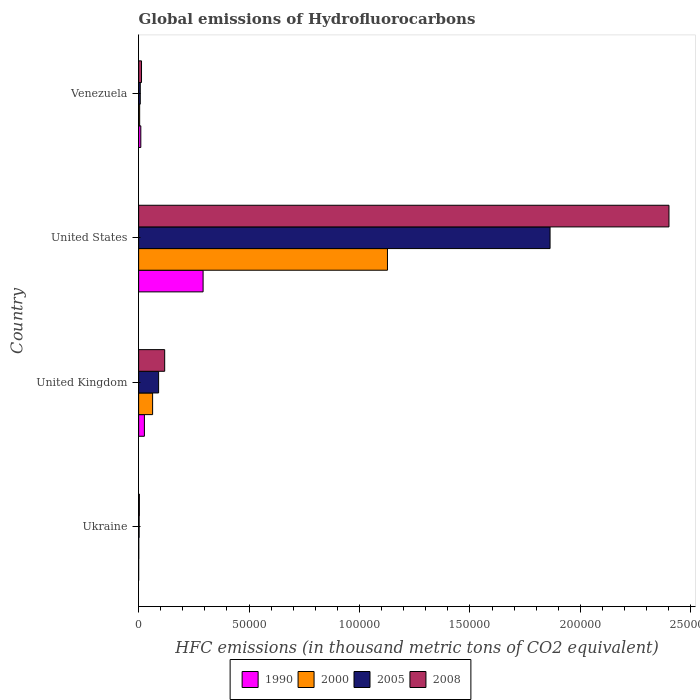What is the label of the 2nd group of bars from the top?
Your answer should be compact. United States. In how many cases, is the number of bars for a given country not equal to the number of legend labels?
Keep it short and to the point. 0. What is the global emissions of Hydrofluorocarbons in 2000 in United States?
Provide a short and direct response. 1.13e+05. Across all countries, what is the maximum global emissions of Hydrofluorocarbons in 2005?
Make the answer very short. 1.86e+05. Across all countries, what is the minimum global emissions of Hydrofluorocarbons in 2008?
Your answer should be compact. 333.5. In which country was the global emissions of Hydrofluorocarbons in 2000 maximum?
Your answer should be compact. United States. In which country was the global emissions of Hydrofluorocarbons in 2008 minimum?
Offer a terse response. Ukraine. What is the total global emissions of Hydrofluorocarbons in 2005 in the graph?
Keep it short and to the point. 1.96e+05. What is the difference between the global emissions of Hydrofluorocarbons in 2000 in Ukraine and that in United Kingdom?
Keep it short and to the point. -6277.8. What is the difference between the global emissions of Hydrofluorocarbons in 1990 in Venezuela and the global emissions of Hydrofluorocarbons in 2008 in United Kingdom?
Ensure brevity in your answer.  -1.08e+04. What is the average global emissions of Hydrofluorocarbons in 2000 per country?
Offer a very short reply. 2.99e+04. What is the difference between the global emissions of Hydrofluorocarbons in 1990 and global emissions of Hydrofluorocarbons in 2005 in United States?
Keep it short and to the point. -1.57e+05. What is the ratio of the global emissions of Hydrofluorocarbons in 2005 in United Kingdom to that in United States?
Your answer should be very brief. 0.05. Is the global emissions of Hydrofluorocarbons in 2008 in United Kingdom less than that in United States?
Your response must be concise. Yes. What is the difference between the highest and the second highest global emissions of Hydrofluorocarbons in 2000?
Provide a succinct answer. 1.06e+05. What is the difference between the highest and the lowest global emissions of Hydrofluorocarbons in 1990?
Provide a succinct answer. 2.92e+04. Is the sum of the global emissions of Hydrofluorocarbons in 1990 in United Kingdom and United States greater than the maximum global emissions of Hydrofluorocarbons in 2000 across all countries?
Offer a terse response. No. Is it the case that in every country, the sum of the global emissions of Hydrofluorocarbons in 2008 and global emissions of Hydrofluorocarbons in 2005 is greater than the sum of global emissions of Hydrofluorocarbons in 1990 and global emissions of Hydrofluorocarbons in 2000?
Offer a very short reply. No. What does the 3rd bar from the top in Ukraine represents?
Give a very brief answer. 2000. Are all the bars in the graph horizontal?
Provide a succinct answer. Yes. What is the difference between two consecutive major ticks on the X-axis?
Make the answer very short. 5.00e+04. Are the values on the major ticks of X-axis written in scientific E-notation?
Provide a short and direct response. No. Does the graph contain any zero values?
Your answer should be very brief. No. Where does the legend appear in the graph?
Ensure brevity in your answer.  Bottom center. What is the title of the graph?
Provide a short and direct response. Global emissions of Hydrofluorocarbons. What is the label or title of the X-axis?
Give a very brief answer. HFC emissions (in thousand metric tons of CO2 equivalent). What is the label or title of the Y-axis?
Provide a succinct answer. Country. What is the HFC emissions (in thousand metric tons of CO2 equivalent) of 1990 in Ukraine?
Your answer should be very brief. 0.1. What is the HFC emissions (in thousand metric tons of CO2 equivalent) of 2000 in Ukraine?
Your answer should be compact. 54.7. What is the HFC emissions (in thousand metric tons of CO2 equivalent) of 2005 in Ukraine?
Keep it short and to the point. 227.2. What is the HFC emissions (in thousand metric tons of CO2 equivalent) of 2008 in Ukraine?
Offer a very short reply. 333.5. What is the HFC emissions (in thousand metric tons of CO2 equivalent) in 1990 in United Kingdom?
Provide a succinct answer. 2617.8. What is the HFC emissions (in thousand metric tons of CO2 equivalent) in 2000 in United Kingdom?
Ensure brevity in your answer.  6332.5. What is the HFC emissions (in thousand metric tons of CO2 equivalent) in 2005 in United Kingdom?
Your response must be concise. 9043.4. What is the HFC emissions (in thousand metric tons of CO2 equivalent) of 2008 in United Kingdom?
Offer a very short reply. 1.18e+04. What is the HFC emissions (in thousand metric tons of CO2 equivalent) of 1990 in United States?
Provide a succinct answer. 2.92e+04. What is the HFC emissions (in thousand metric tons of CO2 equivalent) in 2000 in United States?
Your answer should be compact. 1.13e+05. What is the HFC emissions (in thousand metric tons of CO2 equivalent) in 2005 in United States?
Ensure brevity in your answer.  1.86e+05. What is the HFC emissions (in thousand metric tons of CO2 equivalent) of 2008 in United States?
Offer a terse response. 2.40e+05. What is the HFC emissions (in thousand metric tons of CO2 equivalent) in 1990 in Venezuela?
Keep it short and to the point. 989.6. What is the HFC emissions (in thousand metric tons of CO2 equivalent) in 2000 in Venezuela?
Provide a short and direct response. 468.5. What is the HFC emissions (in thousand metric tons of CO2 equivalent) in 2005 in Venezuela?
Your answer should be compact. 738.4. What is the HFC emissions (in thousand metric tons of CO2 equivalent) of 2008 in Venezuela?
Provide a short and direct response. 1307.1. Across all countries, what is the maximum HFC emissions (in thousand metric tons of CO2 equivalent) of 1990?
Your answer should be compact. 2.92e+04. Across all countries, what is the maximum HFC emissions (in thousand metric tons of CO2 equivalent) in 2000?
Provide a short and direct response. 1.13e+05. Across all countries, what is the maximum HFC emissions (in thousand metric tons of CO2 equivalent) of 2005?
Your answer should be very brief. 1.86e+05. Across all countries, what is the maximum HFC emissions (in thousand metric tons of CO2 equivalent) of 2008?
Ensure brevity in your answer.  2.40e+05. Across all countries, what is the minimum HFC emissions (in thousand metric tons of CO2 equivalent) of 1990?
Give a very brief answer. 0.1. Across all countries, what is the minimum HFC emissions (in thousand metric tons of CO2 equivalent) of 2000?
Offer a terse response. 54.7. Across all countries, what is the minimum HFC emissions (in thousand metric tons of CO2 equivalent) in 2005?
Keep it short and to the point. 227.2. Across all countries, what is the minimum HFC emissions (in thousand metric tons of CO2 equivalent) of 2008?
Your answer should be very brief. 333.5. What is the total HFC emissions (in thousand metric tons of CO2 equivalent) in 1990 in the graph?
Offer a terse response. 3.28e+04. What is the total HFC emissions (in thousand metric tons of CO2 equivalent) of 2000 in the graph?
Offer a very short reply. 1.20e+05. What is the total HFC emissions (in thousand metric tons of CO2 equivalent) of 2005 in the graph?
Offer a very short reply. 1.96e+05. What is the total HFC emissions (in thousand metric tons of CO2 equivalent) in 2008 in the graph?
Ensure brevity in your answer.  2.54e+05. What is the difference between the HFC emissions (in thousand metric tons of CO2 equivalent) of 1990 in Ukraine and that in United Kingdom?
Your answer should be very brief. -2617.7. What is the difference between the HFC emissions (in thousand metric tons of CO2 equivalent) of 2000 in Ukraine and that in United Kingdom?
Your response must be concise. -6277.8. What is the difference between the HFC emissions (in thousand metric tons of CO2 equivalent) of 2005 in Ukraine and that in United Kingdom?
Provide a succinct answer. -8816.2. What is the difference between the HFC emissions (in thousand metric tons of CO2 equivalent) in 2008 in Ukraine and that in United Kingdom?
Keep it short and to the point. -1.15e+04. What is the difference between the HFC emissions (in thousand metric tons of CO2 equivalent) of 1990 in Ukraine and that in United States?
Offer a very short reply. -2.92e+04. What is the difference between the HFC emissions (in thousand metric tons of CO2 equivalent) in 2000 in Ukraine and that in United States?
Make the answer very short. -1.13e+05. What is the difference between the HFC emissions (in thousand metric tons of CO2 equivalent) in 2005 in Ukraine and that in United States?
Make the answer very short. -1.86e+05. What is the difference between the HFC emissions (in thousand metric tons of CO2 equivalent) in 2008 in Ukraine and that in United States?
Offer a very short reply. -2.40e+05. What is the difference between the HFC emissions (in thousand metric tons of CO2 equivalent) of 1990 in Ukraine and that in Venezuela?
Your response must be concise. -989.5. What is the difference between the HFC emissions (in thousand metric tons of CO2 equivalent) of 2000 in Ukraine and that in Venezuela?
Your answer should be compact. -413.8. What is the difference between the HFC emissions (in thousand metric tons of CO2 equivalent) of 2005 in Ukraine and that in Venezuela?
Your response must be concise. -511.2. What is the difference between the HFC emissions (in thousand metric tons of CO2 equivalent) of 2008 in Ukraine and that in Venezuela?
Your answer should be compact. -973.6. What is the difference between the HFC emissions (in thousand metric tons of CO2 equivalent) in 1990 in United Kingdom and that in United States?
Your answer should be very brief. -2.66e+04. What is the difference between the HFC emissions (in thousand metric tons of CO2 equivalent) of 2000 in United Kingdom and that in United States?
Your answer should be very brief. -1.06e+05. What is the difference between the HFC emissions (in thousand metric tons of CO2 equivalent) in 2005 in United Kingdom and that in United States?
Your answer should be very brief. -1.77e+05. What is the difference between the HFC emissions (in thousand metric tons of CO2 equivalent) in 2008 in United Kingdom and that in United States?
Offer a very short reply. -2.28e+05. What is the difference between the HFC emissions (in thousand metric tons of CO2 equivalent) of 1990 in United Kingdom and that in Venezuela?
Your answer should be compact. 1628.2. What is the difference between the HFC emissions (in thousand metric tons of CO2 equivalent) in 2000 in United Kingdom and that in Venezuela?
Offer a terse response. 5864. What is the difference between the HFC emissions (in thousand metric tons of CO2 equivalent) of 2005 in United Kingdom and that in Venezuela?
Keep it short and to the point. 8305. What is the difference between the HFC emissions (in thousand metric tons of CO2 equivalent) in 2008 in United Kingdom and that in Venezuela?
Your answer should be very brief. 1.05e+04. What is the difference between the HFC emissions (in thousand metric tons of CO2 equivalent) of 1990 in United States and that in Venezuela?
Keep it short and to the point. 2.82e+04. What is the difference between the HFC emissions (in thousand metric tons of CO2 equivalent) of 2000 in United States and that in Venezuela?
Offer a very short reply. 1.12e+05. What is the difference between the HFC emissions (in thousand metric tons of CO2 equivalent) of 2005 in United States and that in Venezuela?
Offer a very short reply. 1.86e+05. What is the difference between the HFC emissions (in thousand metric tons of CO2 equivalent) in 2008 in United States and that in Venezuela?
Give a very brief answer. 2.39e+05. What is the difference between the HFC emissions (in thousand metric tons of CO2 equivalent) of 1990 in Ukraine and the HFC emissions (in thousand metric tons of CO2 equivalent) of 2000 in United Kingdom?
Make the answer very short. -6332.4. What is the difference between the HFC emissions (in thousand metric tons of CO2 equivalent) of 1990 in Ukraine and the HFC emissions (in thousand metric tons of CO2 equivalent) of 2005 in United Kingdom?
Ensure brevity in your answer.  -9043.3. What is the difference between the HFC emissions (in thousand metric tons of CO2 equivalent) in 1990 in Ukraine and the HFC emissions (in thousand metric tons of CO2 equivalent) in 2008 in United Kingdom?
Ensure brevity in your answer.  -1.18e+04. What is the difference between the HFC emissions (in thousand metric tons of CO2 equivalent) in 2000 in Ukraine and the HFC emissions (in thousand metric tons of CO2 equivalent) in 2005 in United Kingdom?
Keep it short and to the point. -8988.7. What is the difference between the HFC emissions (in thousand metric tons of CO2 equivalent) of 2000 in Ukraine and the HFC emissions (in thousand metric tons of CO2 equivalent) of 2008 in United Kingdom?
Keep it short and to the point. -1.17e+04. What is the difference between the HFC emissions (in thousand metric tons of CO2 equivalent) of 2005 in Ukraine and the HFC emissions (in thousand metric tons of CO2 equivalent) of 2008 in United Kingdom?
Your response must be concise. -1.16e+04. What is the difference between the HFC emissions (in thousand metric tons of CO2 equivalent) in 1990 in Ukraine and the HFC emissions (in thousand metric tons of CO2 equivalent) in 2000 in United States?
Your response must be concise. -1.13e+05. What is the difference between the HFC emissions (in thousand metric tons of CO2 equivalent) of 1990 in Ukraine and the HFC emissions (in thousand metric tons of CO2 equivalent) of 2005 in United States?
Provide a succinct answer. -1.86e+05. What is the difference between the HFC emissions (in thousand metric tons of CO2 equivalent) of 1990 in Ukraine and the HFC emissions (in thousand metric tons of CO2 equivalent) of 2008 in United States?
Give a very brief answer. -2.40e+05. What is the difference between the HFC emissions (in thousand metric tons of CO2 equivalent) in 2000 in Ukraine and the HFC emissions (in thousand metric tons of CO2 equivalent) in 2005 in United States?
Make the answer very short. -1.86e+05. What is the difference between the HFC emissions (in thousand metric tons of CO2 equivalent) in 2000 in Ukraine and the HFC emissions (in thousand metric tons of CO2 equivalent) in 2008 in United States?
Your answer should be compact. -2.40e+05. What is the difference between the HFC emissions (in thousand metric tons of CO2 equivalent) in 2005 in Ukraine and the HFC emissions (in thousand metric tons of CO2 equivalent) in 2008 in United States?
Provide a succinct answer. -2.40e+05. What is the difference between the HFC emissions (in thousand metric tons of CO2 equivalent) of 1990 in Ukraine and the HFC emissions (in thousand metric tons of CO2 equivalent) of 2000 in Venezuela?
Your answer should be very brief. -468.4. What is the difference between the HFC emissions (in thousand metric tons of CO2 equivalent) of 1990 in Ukraine and the HFC emissions (in thousand metric tons of CO2 equivalent) of 2005 in Venezuela?
Your answer should be compact. -738.3. What is the difference between the HFC emissions (in thousand metric tons of CO2 equivalent) of 1990 in Ukraine and the HFC emissions (in thousand metric tons of CO2 equivalent) of 2008 in Venezuela?
Your response must be concise. -1307. What is the difference between the HFC emissions (in thousand metric tons of CO2 equivalent) in 2000 in Ukraine and the HFC emissions (in thousand metric tons of CO2 equivalent) in 2005 in Venezuela?
Provide a short and direct response. -683.7. What is the difference between the HFC emissions (in thousand metric tons of CO2 equivalent) of 2000 in Ukraine and the HFC emissions (in thousand metric tons of CO2 equivalent) of 2008 in Venezuela?
Keep it short and to the point. -1252.4. What is the difference between the HFC emissions (in thousand metric tons of CO2 equivalent) of 2005 in Ukraine and the HFC emissions (in thousand metric tons of CO2 equivalent) of 2008 in Venezuela?
Your answer should be compact. -1079.9. What is the difference between the HFC emissions (in thousand metric tons of CO2 equivalent) in 1990 in United Kingdom and the HFC emissions (in thousand metric tons of CO2 equivalent) in 2000 in United States?
Your response must be concise. -1.10e+05. What is the difference between the HFC emissions (in thousand metric tons of CO2 equivalent) in 1990 in United Kingdom and the HFC emissions (in thousand metric tons of CO2 equivalent) in 2005 in United States?
Your answer should be compact. -1.84e+05. What is the difference between the HFC emissions (in thousand metric tons of CO2 equivalent) in 1990 in United Kingdom and the HFC emissions (in thousand metric tons of CO2 equivalent) in 2008 in United States?
Your response must be concise. -2.38e+05. What is the difference between the HFC emissions (in thousand metric tons of CO2 equivalent) of 2000 in United Kingdom and the HFC emissions (in thousand metric tons of CO2 equivalent) of 2005 in United States?
Offer a terse response. -1.80e+05. What is the difference between the HFC emissions (in thousand metric tons of CO2 equivalent) in 2000 in United Kingdom and the HFC emissions (in thousand metric tons of CO2 equivalent) in 2008 in United States?
Provide a short and direct response. -2.34e+05. What is the difference between the HFC emissions (in thousand metric tons of CO2 equivalent) of 2005 in United Kingdom and the HFC emissions (in thousand metric tons of CO2 equivalent) of 2008 in United States?
Offer a very short reply. -2.31e+05. What is the difference between the HFC emissions (in thousand metric tons of CO2 equivalent) of 1990 in United Kingdom and the HFC emissions (in thousand metric tons of CO2 equivalent) of 2000 in Venezuela?
Provide a short and direct response. 2149.3. What is the difference between the HFC emissions (in thousand metric tons of CO2 equivalent) in 1990 in United Kingdom and the HFC emissions (in thousand metric tons of CO2 equivalent) in 2005 in Venezuela?
Provide a short and direct response. 1879.4. What is the difference between the HFC emissions (in thousand metric tons of CO2 equivalent) of 1990 in United Kingdom and the HFC emissions (in thousand metric tons of CO2 equivalent) of 2008 in Venezuela?
Keep it short and to the point. 1310.7. What is the difference between the HFC emissions (in thousand metric tons of CO2 equivalent) in 2000 in United Kingdom and the HFC emissions (in thousand metric tons of CO2 equivalent) in 2005 in Venezuela?
Offer a very short reply. 5594.1. What is the difference between the HFC emissions (in thousand metric tons of CO2 equivalent) of 2000 in United Kingdom and the HFC emissions (in thousand metric tons of CO2 equivalent) of 2008 in Venezuela?
Keep it short and to the point. 5025.4. What is the difference between the HFC emissions (in thousand metric tons of CO2 equivalent) in 2005 in United Kingdom and the HFC emissions (in thousand metric tons of CO2 equivalent) in 2008 in Venezuela?
Your answer should be very brief. 7736.3. What is the difference between the HFC emissions (in thousand metric tons of CO2 equivalent) in 1990 in United States and the HFC emissions (in thousand metric tons of CO2 equivalent) in 2000 in Venezuela?
Keep it short and to the point. 2.87e+04. What is the difference between the HFC emissions (in thousand metric tons of CO2 equivalent) in 1990 in United States and the HFC emissions (in thousand metric tons of CO2 equivalent) in 2005 in Venezuela?
Your answer should be very brief. 2.84e+04. What is the difference between the HFC emissions (in thousand metric tons of CO2 equivalent) in 1990 in United States and the HFC emissions (in thousand metric tons of CO2 equivalent) in 2008 in Venezuela?
Your answer should be compact. 2.79e+04. What is the difference between the HFC emissions (in thousand metric tons of CO2 equivalent) of 2000 in United States and the HFC emissions (in thousand metric tons of CO2 equivalent) of 2005 in Venezuela?
Offer a very short reply. 1.12e+05. What is the difference between the HFC emissions (in thousand metric tons of CO2 equivalent) of 2000 in United States and the HFC emissions (in thousand metric tons of CO2 equivalent) of 2008 in Venezuela?
Provide a short and direct response. 1.11e+05. What is the difference between the HFC emissions (in thousand metric tons of CO2 equivalent) in 2005 in United States and the HFC emissions (in thousand metric tons of CO2 equivalent) in 2008 in Venezuela?
Your answer should be compact. 1.85e+05. What is the average HFC emissions (in thousand metric tons of CO2 equivalent) in 1990 per country?
Offer a very short reply. 8198.33. What is the average HFC emissions (in thousand metric tons of CO2 equivalent) in 2000 per country?
Your answer should be very brief. 2.99e+04. What is the average HFC emissions (in thousand metric tons of CO2 equivalent) of 2005 per country?
Your response must be concise. 4.91e+04. What is the average HFC emissions (in thousand metric tons of CO2 equivalent) in 2008 per country?
Your answer should be compact. 6.34e+04. What is the difference between the HFC emissions (in thousand metric tons of CO2 equivalent) in 1990 and HFC emissions (in thousand metric tons of CO2 equivalent) in 2000 in Ukraine?
Your answer should be very brief. -54.6. What is the difference between the HFC emissions (in thousand metric tons of CO2 equivalent) in 1990 and HFC emissions (in thousand metric tons of CO2 equivalent) in 2005 in Ukraine?
Provide a short and direct response. -227.1. What is the difference between the HFC emissions (in thousand metric tons of CO2 equivalent) of 1990 and HFC emissions (in thousand metric tons of CO2 equivalent) of 2008 in Ukraine?
Your answer should be very brief. -333.4. What is the difference between the HFC emissions (in thousand metric tons of CO2 equivalent) in 2000 and HFC emissions (in thousand metric tons of CO2 equivalent) in 2005 in Ukraine?
Offer a terse response. -172.5. What is the difference between the HFC emissions (in thousand metric tons of CO2 equivalent) of 2000 and HFC emissions (in thousand metric tons of CO2 equivalent) of 2008 in Ukraine?
Keep it short and to the point. -278.8. What is the difference between the HFC emissions (in thousand metric tons of CO2 equivalent) of 2005 and HFC emissions (in thousand metric tons of CO2 equivalent) of 2008 in Ukraine?
Give a very brief answer. -106.3. What is the difference between the HFC emissions (in thousand metric tons of CO2 equivalent) of 1990 and HFC emissions (in thousand metric tons of CO2 equivalent) of 2000 in United Kingdom?
Give a very brief answer. -3714.7. What is the difference between the HFC emissions (in thousand metric tons of CO2 equivalent) of 1990 and HFC emissions (in thousand metric tons of CO2 equivalent) of 2005 in United Kingdom?
Ensure brevity in your answer.  -6425.6. What is the difference between the HFC emissions (in thousand metric tons of CO2 equivalent) of 1990 and HFC emissions (in thousand metric tons of CO2 equivalent) of 2008 in United Kingdom?
Ensure brevity in your answer.  -9178.2. What is the difference between the HFC emissions (in thousand metric tons of CO2 equivalent) in 2000 and HFC emissions (in thousand metric tons of CO2 equivalent) in 2005 in United Kingdom?
Ensure brevity in your answer.  -2710.9. What is the difference between the HFC emissions (in thousand metric tons of CO2 equivalent) in 2000 and HFC emissions (in thousand metric tons of CO2 equivalent) in 2008 in United Kingdom?
Make the answer very short. -5463.5. What is the difference between the HFC emissions (in thousand metric tons of CO2 equivalent) of 2005 and HFC emissions (in thousand metric tons of CO2 equivalent) of 2008 in United Kingdom?
Your answer should be very brief. -2752.6. What is the difference between the HFC emissions (in thousand metric tons of CO2 equivalent) of 1990 and HFC emissions (in thousand metric tons of CO2 equivalent) of 2000 in United States?
Make the answer very short. -8.35e+04. What is the difference between the HFC emissions (in thousand metric tons of CO2 equivalent) in 1990 and HFC emissions (in thousand metric tons of CO2 equivalent) in 2005 in United States?
Keep it short and to the point. -1.57e+05. What is the difference between the HFC emissions (in thousand metric tons of CO2 equivalent) of 1990 and HFC emissions (in thousand metric tons of CO2 equivalent) of 2008 in United States?
Ensure brevity in your answer.  -2.11e+05. What is the difference between the HFC emissions (in thousand metric tons of CO2 equivalent) in 2000 and HFC emissions (in thousand metric tons of CO2 equivalent) in 2005 in United States?
Your answer should be compact. -7.36e+04. What is the difference between the HFC emissions (in thousand metric tons of CO2 equivalent) in 2000 and HFC emissions (in thousand metric tons of CO2 equivalent) in 2008 in United States?
Your response must be concise. -1.27e+05. What is the difference between the HFC emissions (in thousand metric tons of CO2 equivalent) of 2005 and HFC emissions (in thousand metric tons of CO2 equivalent) of 2008 in United States?
Your response must be concise. -5.38e+04. What is the difference between the HFC emissions (in thousand metric tons of CO2 equivalent) of 1990 and HFC emissions (in thousand metric tons of CO2 equivalent) of 2000 in Venezuela?
Offer a terse response. 521.1. What is the difference between the HFC emissions (in thousand metric tons of CO2 equivalent) in 1990 and HFC emissions (in thousand metric tons of CO2 equivalent) in 2005 in Venezuela?
Make the answer very short. 251.2. What is the difference between the HFC emissions (in thousand metric tons of CO2 equivalent) in 1990 and HFC emissions (in thousand metric tons of CO2 equivalent) in 2008 in Venezuela?
Give a very brief answer. -317.5. What is the difference between the HFC emissions (in thousand metric tons of CO2 equivalent) of 2000 and HFC emissions (in thousand metric tons of CO2 equivalent) of 2005 in Venezuela?
Ensure brevity in your answer.  -269.9. What is the difference between the HFC emissions (in thousand metric tons of CO2 equivalent) of 2000 and HFC emissions (in thousand metric tons of CO2 equivalent) of 2008 in Venezuela?
Ensure brevity in your answer.  -838.6. What is the difference between the HFC emissions (in thousand metric tons of CO2 equivalent) in 2005 and HFC emissions (in thousand metric tons of CO2 equivalent) in 2008 in Venezuela?
Your answer should be very brief. -568.7. What is the ratio of the HFC emissions (in thousand metric tons of CO2 equivalent) in 1990 in Ukraine to that in United Kingdom?
Give a very brief answer. 0. What is the ratio of the HFC emissions (in thousand metric tons of CO2 equivalent) in 2000 in Ukraine to that in United Kingdom?
Give a very brief answer. 0.01. What is the ratio of the HFC emissions (in thousand metric tons of CO2 equivalent) in 2005 in Ukraine to that in United Kingdom?
Offer a terse response. 0.03. What is the ratio of the HFC emissions (in thousand metric tons of CO2 equivalent) in 2008 in Ukraine to that in United Kingdom?
Your answer should be very brief. 0.03. What is the ratio of the HFC emissions (in thousand metric tons of CO2 equivalent) of 1990 in Ukraine to that in United States?
Offer a very short reply. 0. What is the ratio of the HFC emissions (in thousand metric tons of CO2 equivalent) of 2000 in Ukraine to that in United States?
Provide a short and direct response. 0. What is the ratio of the HFC emissions (in thousand metric tons of CO2 equivalent) in 2005 in Ukraine to that in United States?
Your answer should be very brief. 0. What is the ratio of the HFC emissions (in thousand metric tons of CO2 equivalent) in 2008 in Ukraine to that in United States?
Your response must be concise. 0. What is the ratio of the HFC emissions (in thousand metric tons of CO2 equivalent) of 2000 in Ukraine to that in Venezuela?
Make the answer very short. 0.12. What is the ratio of the HFC emissions (in thousand metric tons of CO2 equivalent) of 2005 in Ukraine to that in Venezuela?
Your answer should be compact. 0.31. What is the ratio of the HFC emissions (in thousand metric tons of CO2 equivalent) of 2008 in Ukraine to that in Venezuela?
Offer a very short reply. 0.26. What is the ratio of the HFC emissions (in thousand metric tons of CO2 equivalent) of 1990 in United Kingdom to that in United States?
Your answer should be compact. 0.09. What is the ratio of the HFC emissions (in thousand metric tons of CO2 equivalent) in 2000 in United Kingdom to that in United States?
Your answer should be very brief. 0.06. What is the ratio of the HFC emissions (in thousand metric tons of CO2 equivalent) in 2005 in United Kingdom to that in United States?
Keep it short and to the point. 0.05. What is the ratio of the HFC emissions (in thousand metric tons of CO2 equivalent) of 2008 in United Kingdom to that in United States?
Your answer should be compact. 0.05. What is the ratio of the HFC emissions (in thousand metric tons of CO2 equivalent) in 1990 in United Kingdom to that in Venezuela?
Provide a succinct answer. 2.65. What is the ratio of the HFC emissions (in thousand metric tons of CO2 equivalent) of 2000 in United Kingdom to that in Venezuela?
Keep it short and to the point. 13.52. What is the ratio of the HFC emissions (in thousand metric tons of CO2 equivalent) in 2005 in United Kingdom to that in Venezuela?
Make the answer very short. 12.25. What is the ratio of the HFC emissions (in thousand metric tons of CO2 equivalent) in 2008 in United Kingdom to that in Venezuela?
Keep it short and to the point. 9.02. What is the ratio of the HFC emissions (in thousand metric tons of CO2 equivalent) of 1990 in United States to that in Venezuela?
Ensure brevity in your answer.  29.49. What is the ratio of the HFC emissions (in thousand metric tons of CO2 equivalent) of 2000 in United States to that in Venezuela?
Your response must be concise. 240.48. What is the ratio of the HFC emissions (in thousand metric tons of CO2 equivalent) of 2005 in United States to that in Venezuela?
Provide a succinct answer. 252.29. What is the ratio of the HFC emissions (in thousand metric tons of CO2 equivalent) of 2008 in United States to that in Venezuela?
Your answer should be very brief. 183.71. What is the difference between the highest and the second highest HFC emissions (in thousand metric tons of CO2 equivalent) of 1990?
Make the answer very short. 2.66e+04. What is the difference between the highest and the second highest HFC emissions (in thousand metric tons of CO2 equivalent) in 2000?
Offer a very short reply. 1.06e+05. What is the difference between the highest and the second highest HFC emissions (in thousand metric tons of CO2 equivalent) of 2005?
Provide a short and direct response. 1.77e+05. What is the difference between the highest and the second highest HFC emissions (in thousand metric tons of CO2 equivalent) in 2008?
Ensure brevity in your answer.  2.28e+05. What is the difference between the highest and the lowest HFC emissions (in thousand metric tons of CO2 equivalent) in 1990?
Give a very brief answer. 2.92e+04. What is the difference between the highest and the lowest HFC emissions (in thousand metric tons of CO2 equivalent) in 2000?
Make the answer very short. 1.13e+05. What is the difference between the highest and the lowest HFC emissions (in thousand metric tons of CO2 equivalent) in 2005?
Offer a very short reply. 1.86e+05. What is the difference between the highest and the lowest HFC emissions (in thousand metric tons of CO2 equivalent) of 2008?
Offer a terse response. 2.40e+05. 